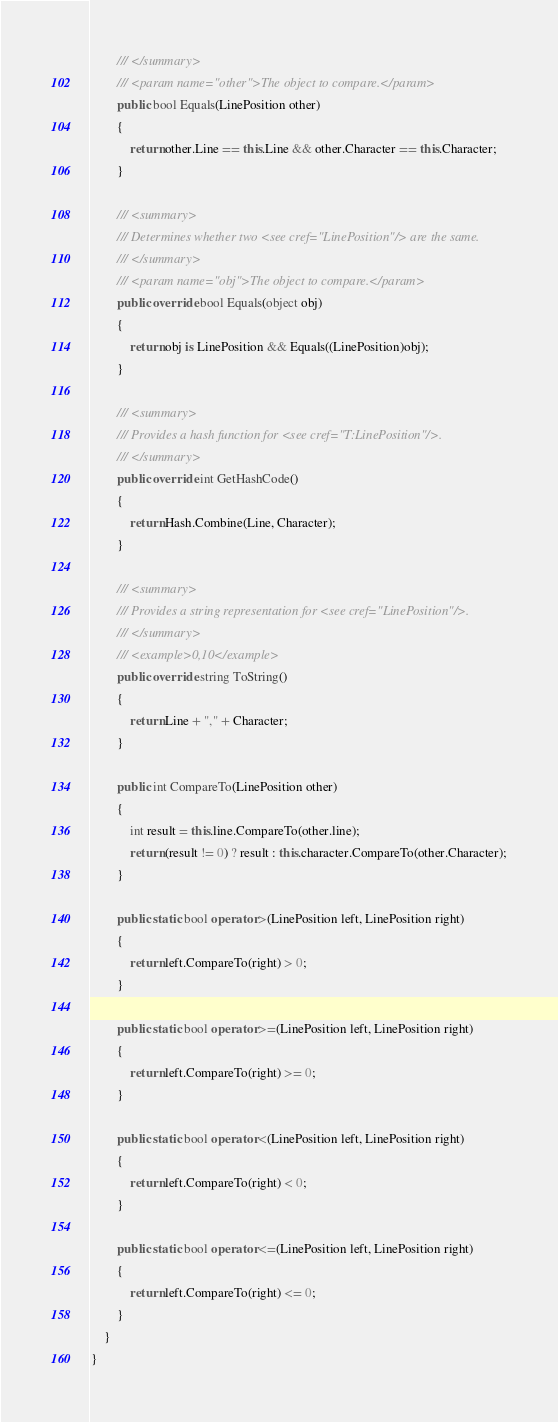Convert code to text. <code><loc_0><loc_0><loc_500><loc_500><_C#_>        /// </summary>
        /// <param name="other">The object to compare.</param>
        public bool Equals(LinePosition other)
        {
            return other.Line == this.Line && other.Character == this.Character;
        }

        /// <summary>
        /// Determines whether two <see cref="LinePosition"/> are the same.
        /// </summary>
        /// <param name="obj">The object to compare.</param>
        public override bool Equals(object obj)
        {
            return obj is LinePosition && Equals((LinePosition)obj);
        }

        /// <summary>
        /// Provides a hash function for <see cref="T:LinePosition"/>.
        /// </summary>
        public override int GetHashCode()
        {
            return Hash.Combine(Line, Character);
        }

        /// <summary>
        /// Provides a string representation for <see cref="LinePosition"/>.
        /// </summary>
        /// <example>0,10</example>
        public override string ToString()
        {
            return Line + "," + Character;
        }

        public int CompareTo(LinePosition other)
        {
            int result = this.line.CompareTo(other.line);
            return (result != 0) ? result : this.character.CompareTo(other.Character);
        }

        public static bool operator >(LinePosition left, LinePosition right)
        {
            return left.CompareTo(right) > 0;
        }

        public static bool operator >=(LinePosition left, LinePosition right)
        {
            return left.CompareTo(right) >= 0;
        }

        public static bool operator <(LinePosition left, LinePosition right)
        {
            return left.CompareTo(right) < 0;
        }

        public static bool operator <=(LinePosition left, LinePosition right)
        {
            return left.CompareTo(right) <= 0;
        }
    }
}</code> 